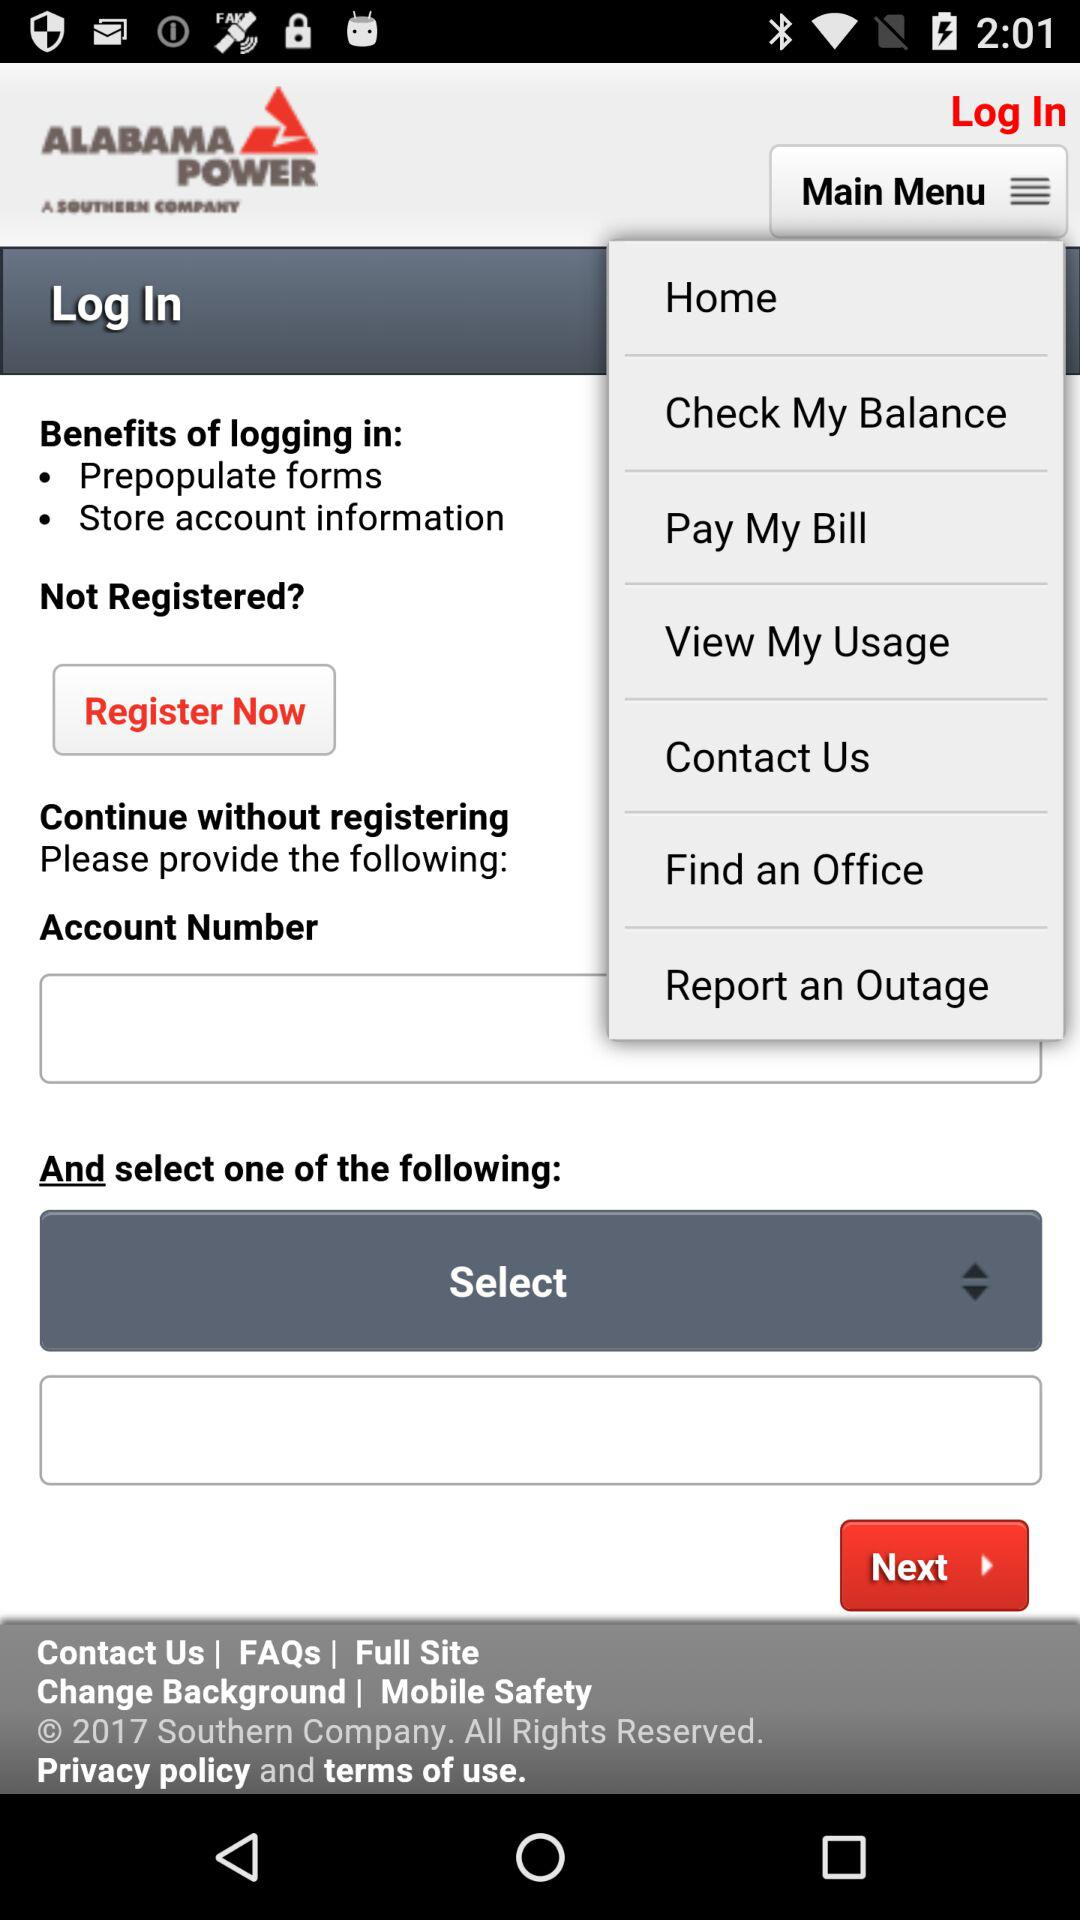What is the account number?
When the provided information is insufficient, respond with <no answer>. <no answer> 